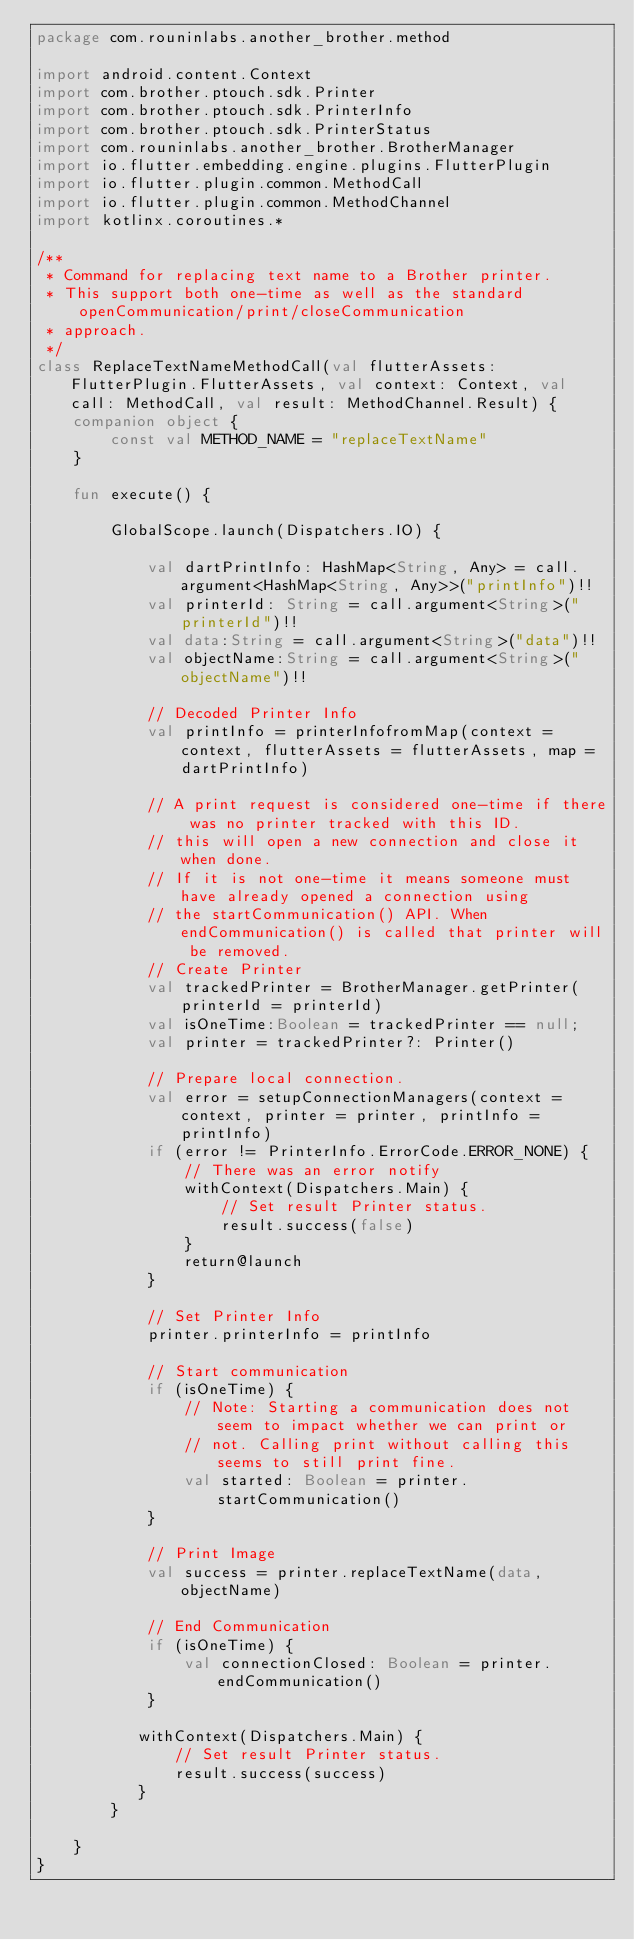Convert code to text. <code><loc_0><loc_0><loc_500><loc_500><_Kotlin_>package com.rouninlabs.another_brother.method

import android.content.Context
import com.brother.ptouch.sdk.Printer
import com.brother.ptouch.sdk.PrinterInfo
import com.brother.ptouch.sdk.PrinterStatus
import com.rouninlabs.another_brother.BrotherManager
import io.flutter.embedding.engine.plugins.FlutterPlugin
import io.flutter.plugin.common.MethodCall
import io.flutter.plugin.common.MethodChannel
import kotlinx.coroutines.*

/**
 * Command for replacing text name to a Brother printer.
 * This support both one-time as well as the standard openCommunication/print/closeCommunication
 * approach.
 */
class ReplaceTextNameMethodCall(val flutterAssets: FlutterPlugin.FlutterAssets, val context: Context, val call: MethodCall, val result: MethodChannel.Result) {
    companion object {
        const val METHOD_NAME = "replaceTextName"
    }

    fun execute() {

        GlobalScope.launch(Dispatchers.IO) {

            val dartPrintInfo: HashMap<String, Any> = call.argument<HashMap<String, Any>>("printInfo")!!
            val printerId: String = call.argument<String>("printerId")!!
            val data:String = call.argument<String>("data")!!
            val objectName:String = call.argument<String>("objectName")!!

            // Decoded Printer Info
            val printInfo = printerInfofromMap(context = context, flutterAssets = flutterAssets, map = dartPrintInfo)

            // A print request is considered one-time if there was no printer tracked with this ID.
            // this will open a new connection and close it when done.
            // If it is not one-time it means someone must have already opened a connection using
            // the startCommunication() API. When endCommunication() is called that printer will be removed.
            // Create Printer
            val trackedPrinter = BrotherManager.getPrinter(printerId = printerId)
            val isOneTime:Boolean = trackedPrinter == null;
            val printer = trackedPrinter?: Printer()

            // Prepare local connection.
            val error = setupConnectionManagers(context = context, printer = printer, printInfo = printInfo)
            if (error != PrinterInfo.ErrorCode.ERROR_NONE) {
                // There was an error notify
                withContext(Dispatchers.Main) {
                    // Set result Printer status.
                    result.success(false)
                }
                return@launch
            }

            // Set Printer Info
            printer.printerInfo = printInfo

            // Start communication
            if (isOneTime) {
                // Note: Starting a communication does not seem to impact whether we can print or
                // not. Calling print without calling this seems to still print fine.
                val started: Boolean = printer.startCommunication()
            }

            // Print Image
            val success = printer.replaceTextName(data, objectName)

            // End Communication
            if (isOneTime) {
                val connectionClosed: Boolean = printer.endCommunication()
            }

           withContext(Dispatchers.Main) {
               // Set result Printer status.
               result.success(success)
           }
        }

    }
}</code> 